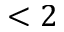<formula> <loc_0><loc_0><loc_500><loc_500>< 2</formula> 